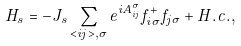<formula> <loc_0><loc_0><loc_500><loc_500>H _ { s } = - J _ { s } \sum _ { < i j > , \sigma } e ^ { i A _ { i j } ^ { \sigma } } f _ { i \sigma } ^ { + } f _ { j \sigma } + H . c . ,</formula> 